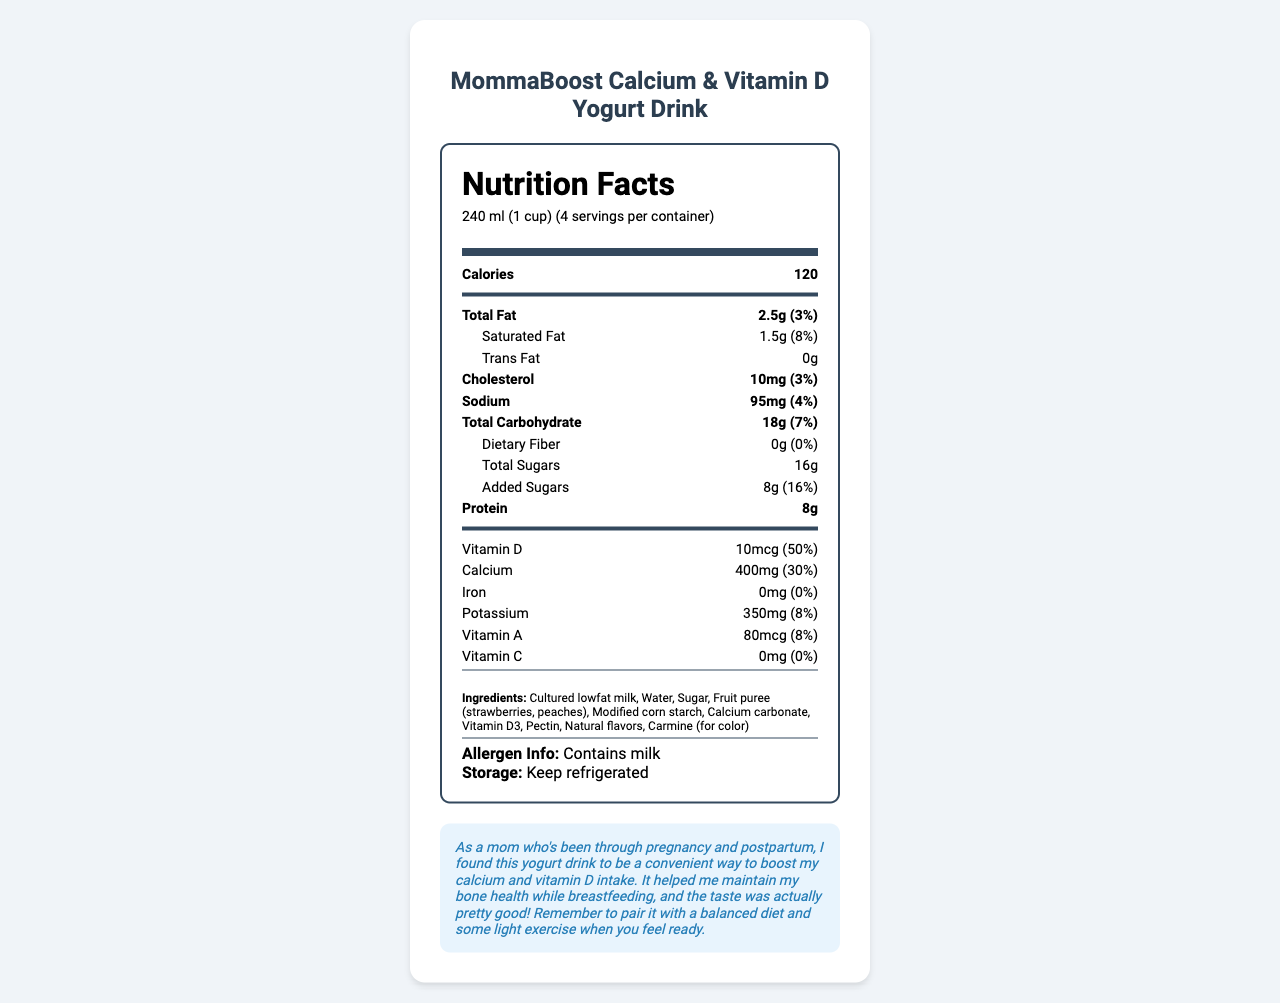what is the serving size of the yogurt drink? The serving size is clearly stated at the top of the document.
Answer: 240 ml (1 cup) how many calories are there per serving? The document lists the calories for each serving directly under the serving size information.
Answer: 120 what percentage of daily vitamin D does this product provide? The Nutrition Facts section states that the product provides 10mcg of Vitamin D, which is 50% of the daily value.
Answer: 50% which ingredient is used for color in this yogurt drink? The Ingredients section lists Carmine as the color additive.
Answer: Carmine does this product contain any dietary fiber? The Nutrition Facts indicate that the product has 0g of dietary fiber.
Answer: No how much protein is in a single serving of this yogurt drink? The protein content per serving is specified as 8g in the Nutrition Facts section.
Answer: 8g what is the total carbohydrate content per serving? A. 8g B. 16g C. 18g D. 20g The document states that the total carbohydrate content is 18g per serving.
Answer: C what allergens are found in this product? A. Milk B. Nuts C. Wheat D. Soy The allergen information specifies that the product contains milk.
Answer: A is this yogurt drink high in calcium? The drink provides 30% of the daily value for calcium, which is relatively high.
Answer: Yes should the yogurt drink be stored at room temperature? The storage instructions clearly state to keep it refrigerated.
Answer: No describe the main purpose of this document The document details the nutritional information of the yogurt drink, mentioning its serving size, calorie count, and various nutrients. It emphasizes the high calcium and vitamin D content essential for postpartum bone health and includes specific ingredients, storage guidelines, allergen info, and a personal note on its benefits.
Answer: The document provides the nutrition facts, ingredients, storage instructions, and allergen information for the MommaBoost Calcium & Vitamin D Yogurt Drink. It focuses on the nutritional benefits for postpartum bone health, specifically highlighting the high content of calcium and vitamin D. There's also a personal note on its benefits for new mothers. how much sugar has been added to the yogurt drink? The Nutrition Facts section lists added sugars as 8g.
Answer: 8g is this product a good source of iron? The Nutrition Facts state that the product contains 0mg of iron, providing 0% of the daily value.
Answer: No can you take this yogurt drink if you are lactose intolerant? The document mentions that the product contains milk, but it does not specify if it contains lactose or if there is a lactose-free version available.
Answer: Not enough information 